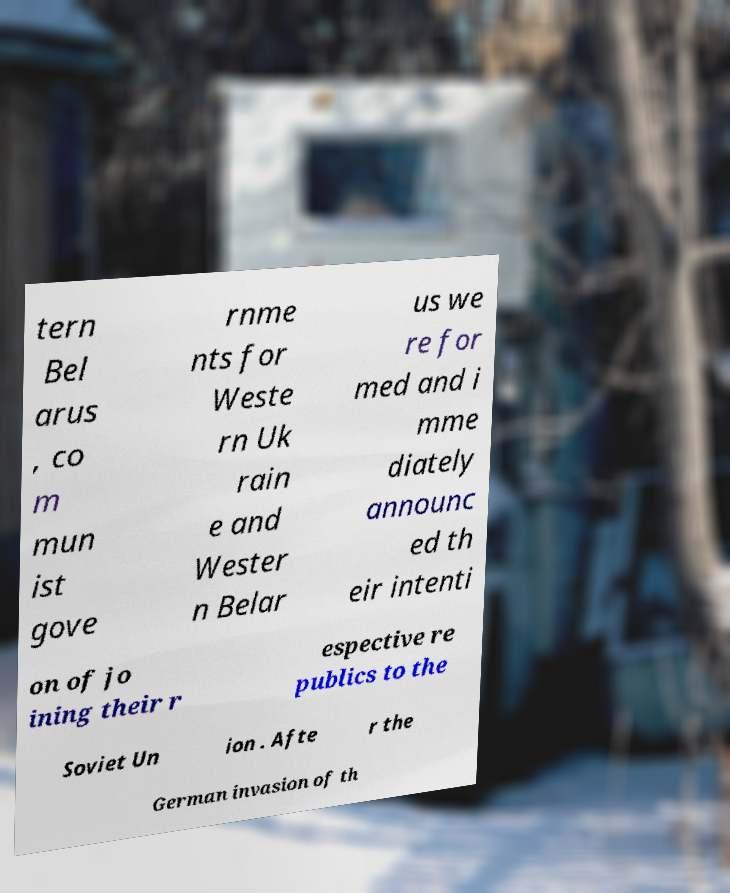Can you accurately transcribe the text from the provided image for me? tern Bel arus , co m mun ist gove rnme nts for Weste rn Uk rain e and Wester n Belar us we re for med and i mme diately announc ed th eir intenti on of jo ining their r espective re publics to the Soviet Un ion . Afte r the German invasion of th 